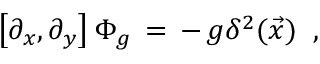<formula> <loc_0><loc_0><loc_500><loc_500>\left [ \partial _ { x } , \partial _ { y } \right ] \Phi _ { g } \, = \, - \, g \delta ^ { 2 } ( \vec { x } ) \, ,</formula> 